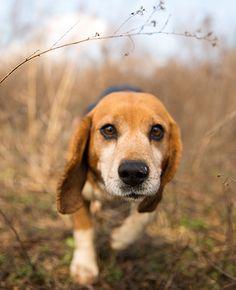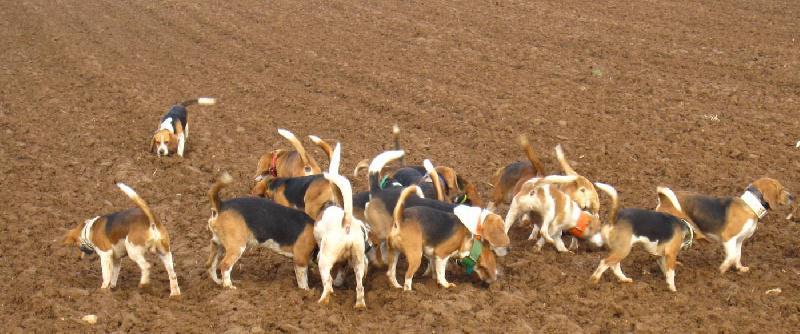The first image is the image on the left, the second image is the image on the right. Analyze the images presented: Is the assertion "No image contains more than one beagle dog, and at least one dog looks directly at the camera." valid? Answer yes or no. No. The first image is the image on the left, the second image is the image on the right. Considering the images on both sides, is "Each image shows exactly one beagle, and at least one beagle is looking at the camera." valid? Answer yes or no. No. 